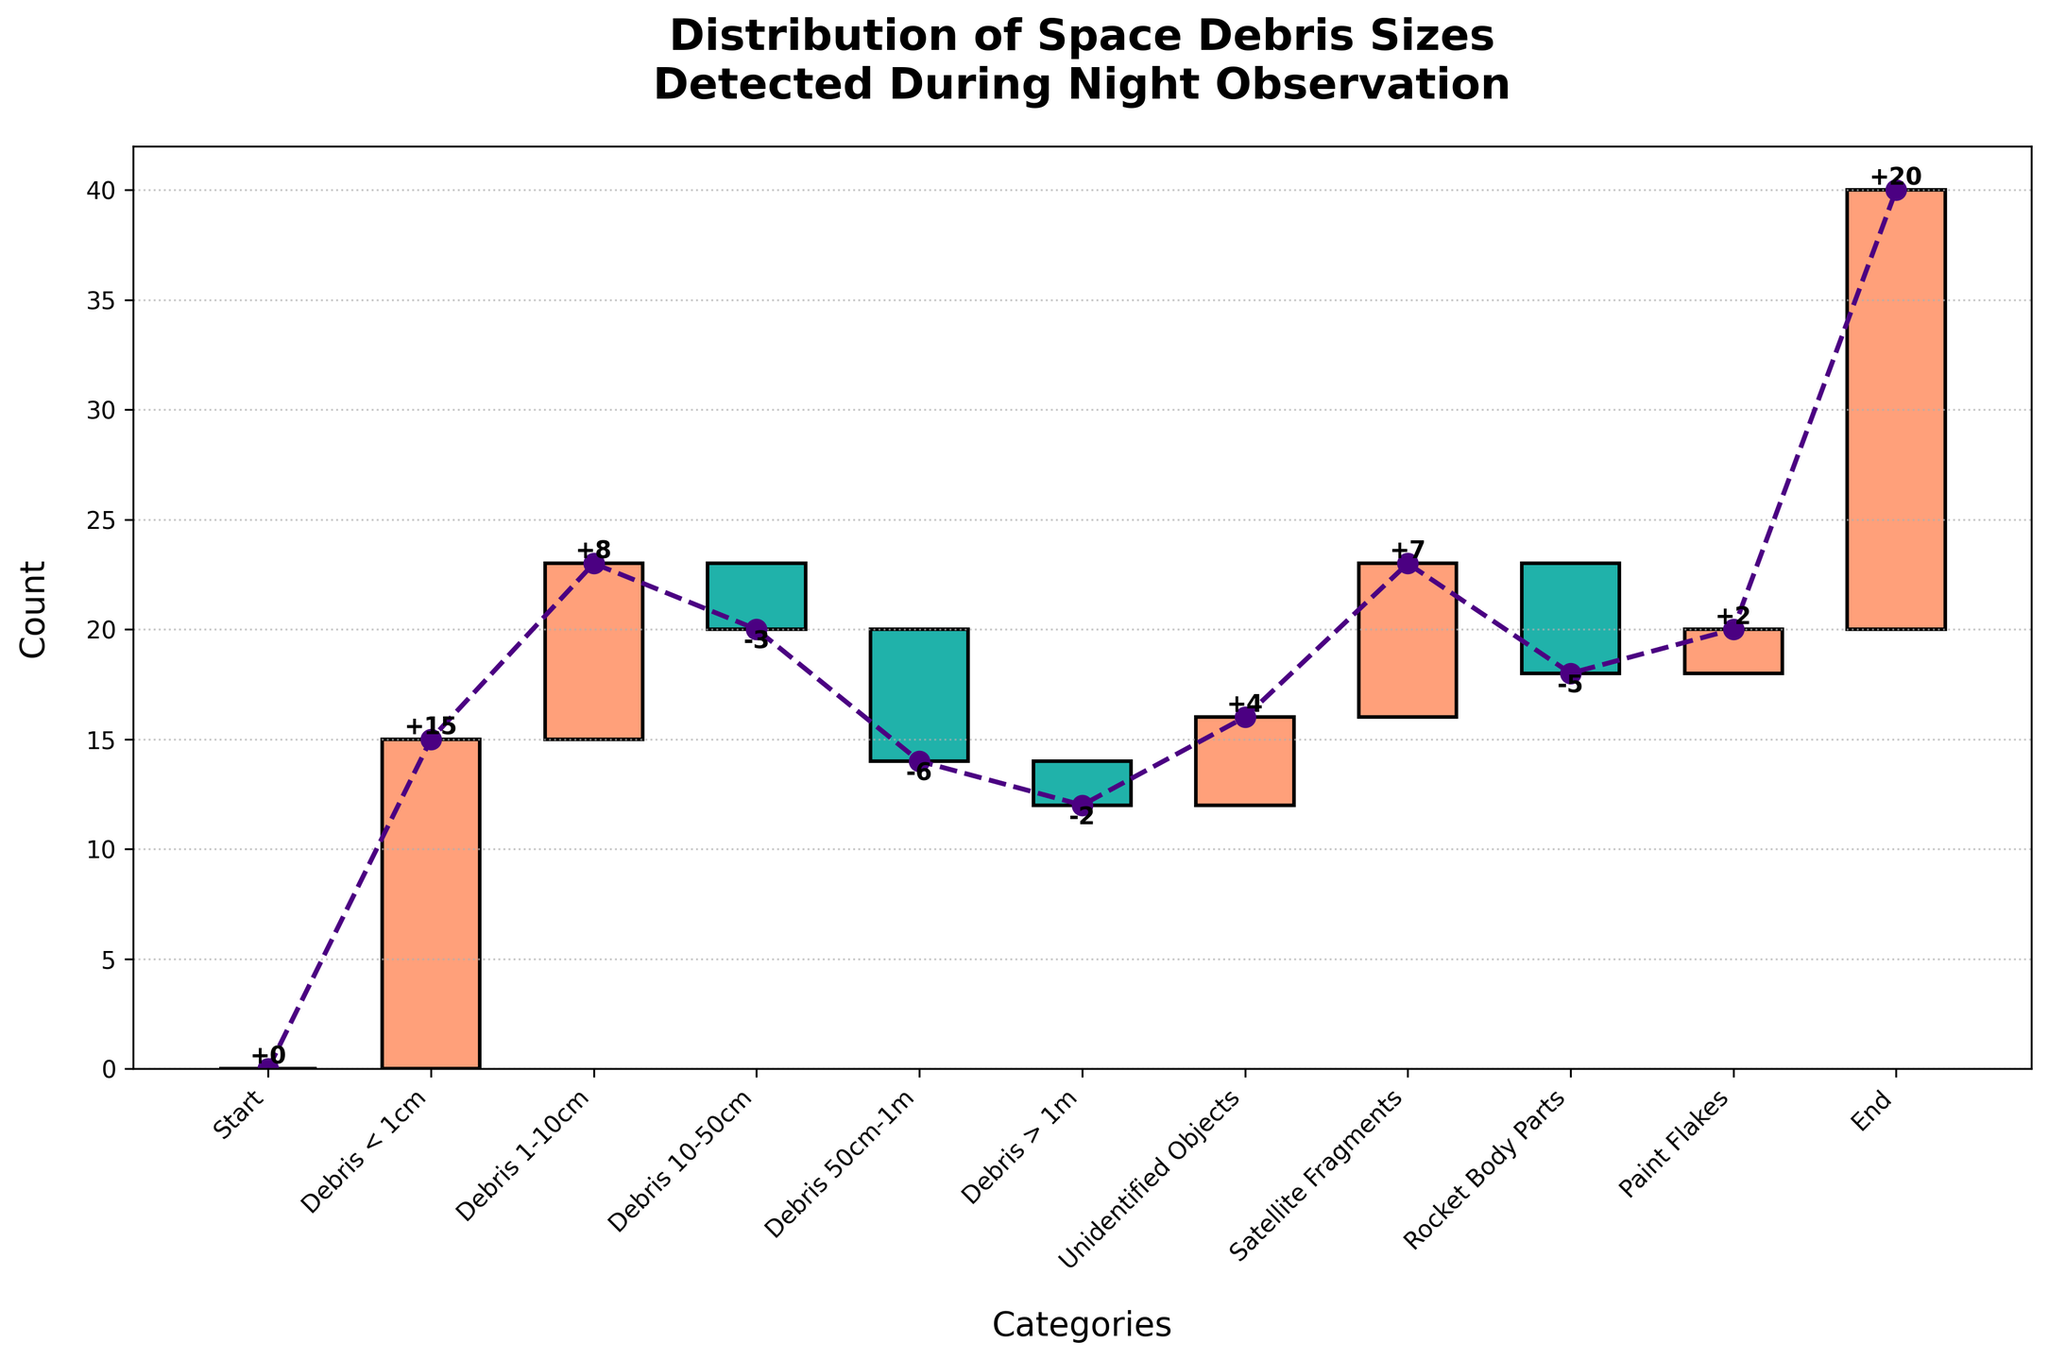What is the title of the chart? The title of the chart is displayed at the top of the figure, summarizing the content of the chart.
Answer: Distribution of Space Debris Sizes Detected During Night Observation What debris size category has the highest positive value? By looking at the values of all the categories, the one with the highest positive value is the category with the most significant bar height above the baseline.
Answer: Debris < 1cm Which category contributes the most negatively to the cumulative count? By identifying the category with the lowest value, observed as the largest bar below the baseline, we can determine the most significant negative contribution.
Answer: Rocket Body Parts What is the final cumulative count at the end of all observations? The final cumulative count is found by looking at the endpoint of the cumulative line, where it intersects the last category.
Answer: 20 What is the net change in the cumulative count between Debris < 1cm and Debris 1-10cm? Calculate the difference between the cumulative values after Debris < 1cm and Debris 1-10cm. This involves finding the sums up to these points.
Answer: -7 How does the number of Unidentified Objects compare to the number of Paint Flakes? Compare the values assigned to Unidentified Objects and Paint Flakes to find which one is larger or if they are the same.
Answer: Unidentified Objects are greater Which category directly follows Debris 50cm-1m in the chart? Observe the order of categories as listed on the x-axis to determine which category comes immediately after Debris 50cm-1m.
Answer: Debris > 1m What is the total count of positive values across all categories? Sum all the positive values from the data to find the total count of positively contributing categories.
Answer: 36 What is the average value of all debris size categories? Add the values of all debris size categories, then divide by the total number of these categories.
Answer: 2.33 How many categories showed a negative value, and what is their combined total? Count all the categories with negative values and sum these values to get the combined negative total.
Answer: 4 categories, -16 